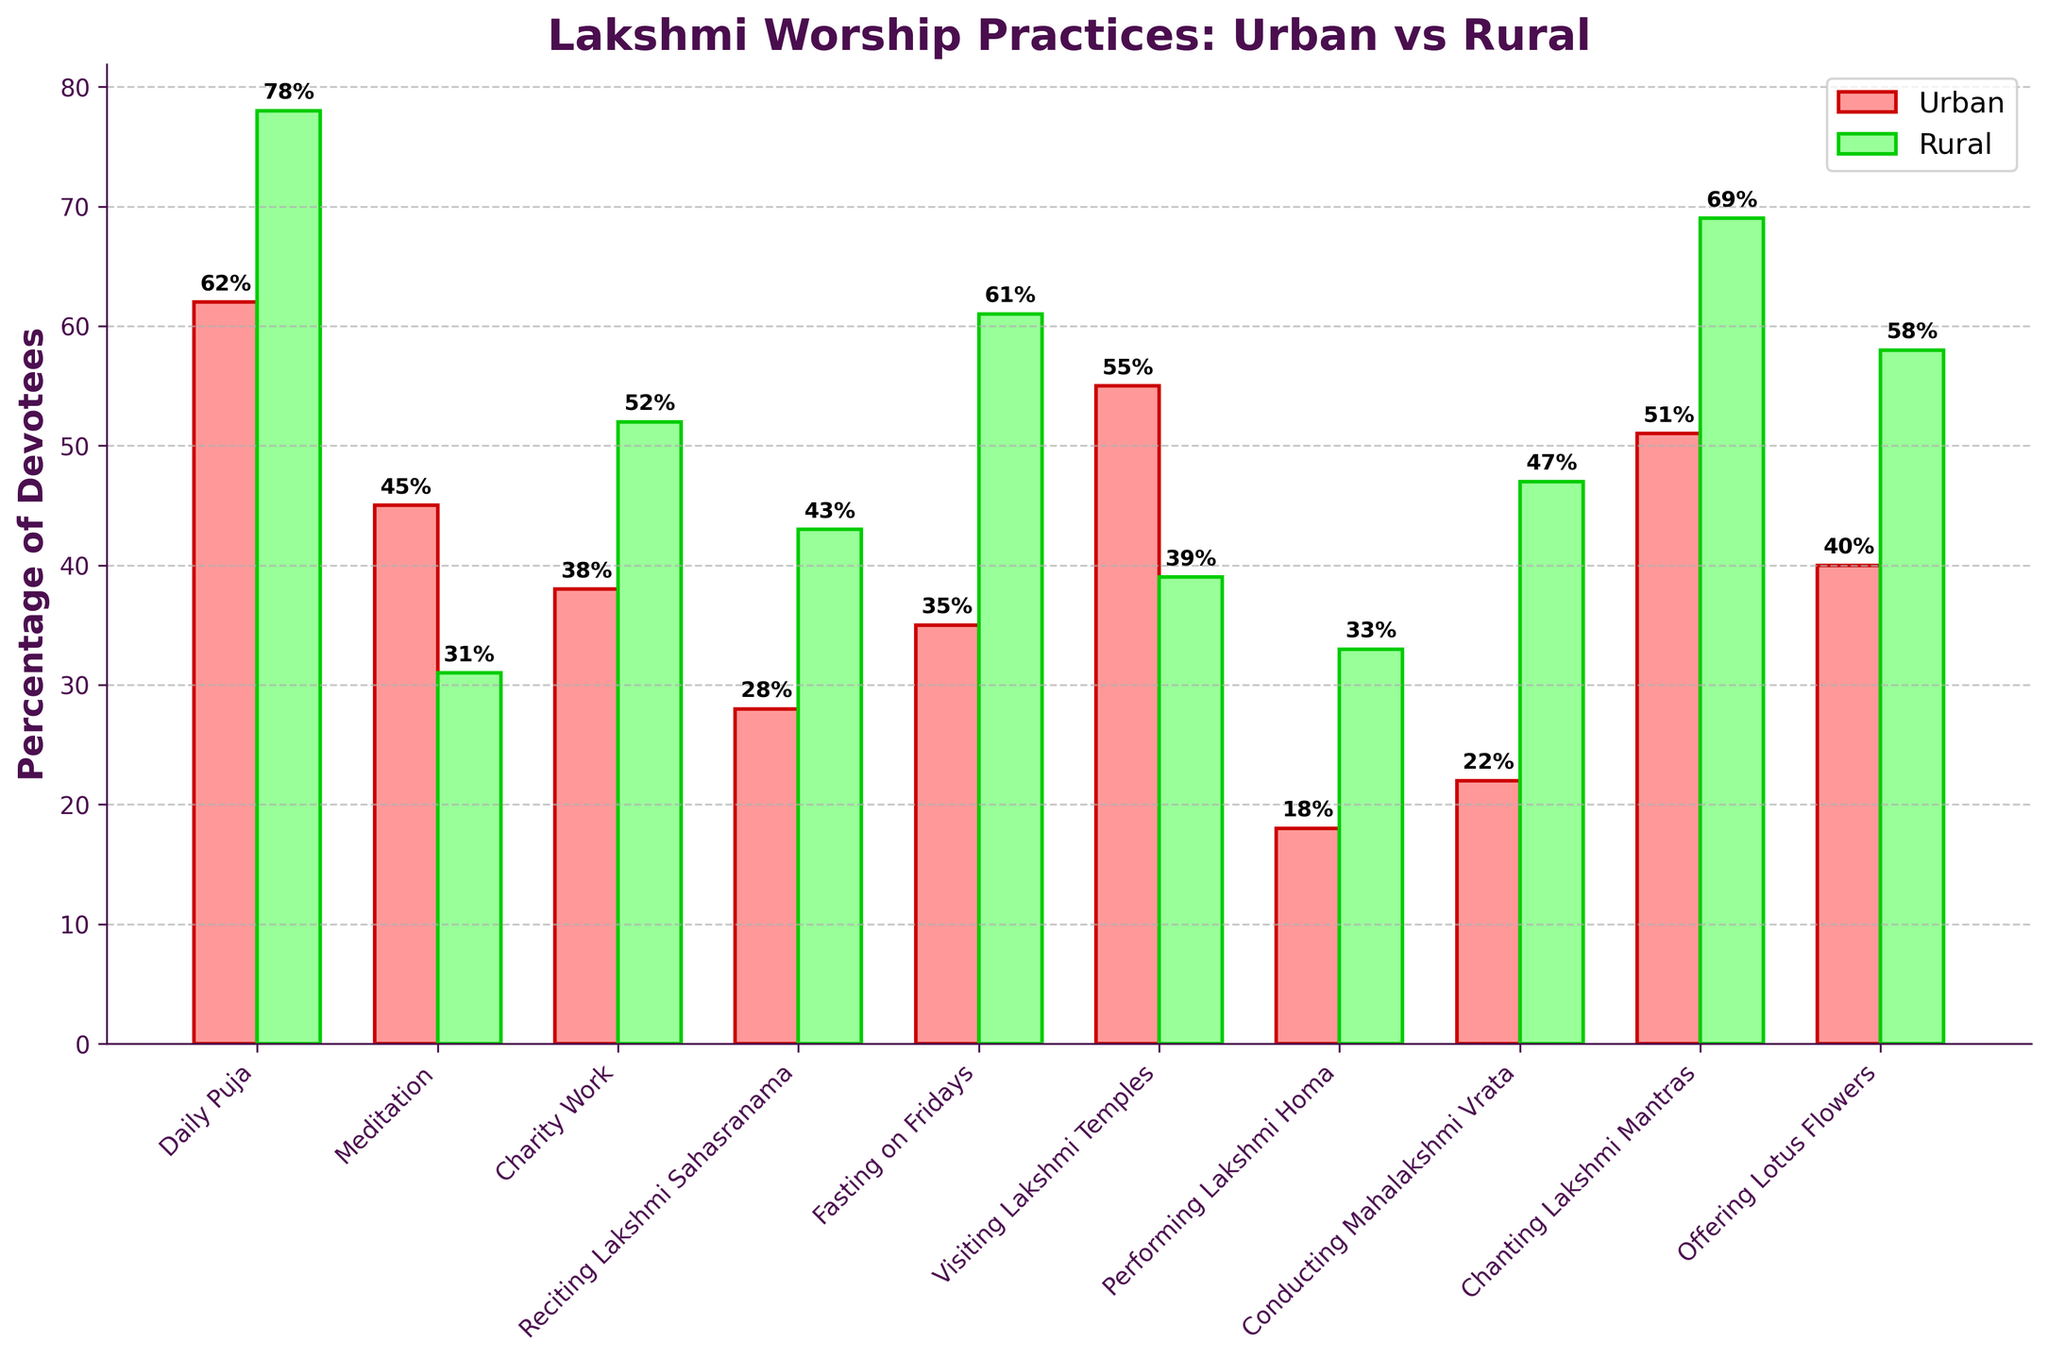Which form of worship has the highest percentage of devotees in rural areas? The chart shows the percentage for each form of worship. By visually comparing the bars representing rural areas, 'Daily Puja' at 78% is the highest.
Answer: Daily Puja Which practice has a larger percentage of urban devotees compared to rural devotees? By comparing the urban and rural bars for each worship form, 'Meditation,' 'Visiting Lakshmi Temples,' and 'Chanting Lakshmi Mantras' have larger urban percentages, with 'Meditation' (Urban: 45%, Rural: 31%) being one example.
Answer: Meditation What is the total percentage of rural devotees engaging in 'Charity Work,' 'Performing Lakshmi Homa,' and 'Conducting Mahalakshmi Vrata'? Add the rural percentages for 'Charity Work' (52%), 'Performing Lakshmi Homa' (33%), and 'Conducting Mahalakshmi Vrata' (47%). Total = 52 + 33 + 47 = 132.
Answer: 132 By what percentage is 'Daily Puja' more popular in rural areas compared to urban areas? Subtract the urban percentage of 'Daily Puja' (62%) from the rural percentage (78%). 78 - 62 = 16.
Answer: 16 Which form of worship shows the greatest difference in percentage between urban and rural areas? Calculate the difference for each form of worship and compare. 'Fasting on Fridays' shows the greatest difference: Rural (61%) - Urban (35%) = 26.
Answer: Fasting on Fridays What is the average percentage of urban devotees engaging in 'Meditation,' 'Charity Work,' and 'Reciting Lakshmi Sahasranama'? Add the urban percentages for 'Meditation' (45%), 'Charity Work' (38%), and 'Reciting Lakshmi Sahasranama' (28%), then divide by 3. (45 + 38 + 28) / 3 = 37.
Answer: 37 Which form of worship has an almost equal percentage of devotees in both urban and rural areas? By comparing the heights of urban and rural bars, the form of worship with the closest percentages is 'Visiting Lakshmi Temples' (Urban: 55%, Rural: 39%).
Answer: Visiting Lakshmi Temples What is the median percentage of urban devotees for the given forms of worship? List the urban percentages in ascending order: 18, 22, 28, 35, 38, 40, 45, 51, 55, 62. The median is the average of the 5th and 6th values. (38 + 40) / 2 = 39.
Answer: 39 